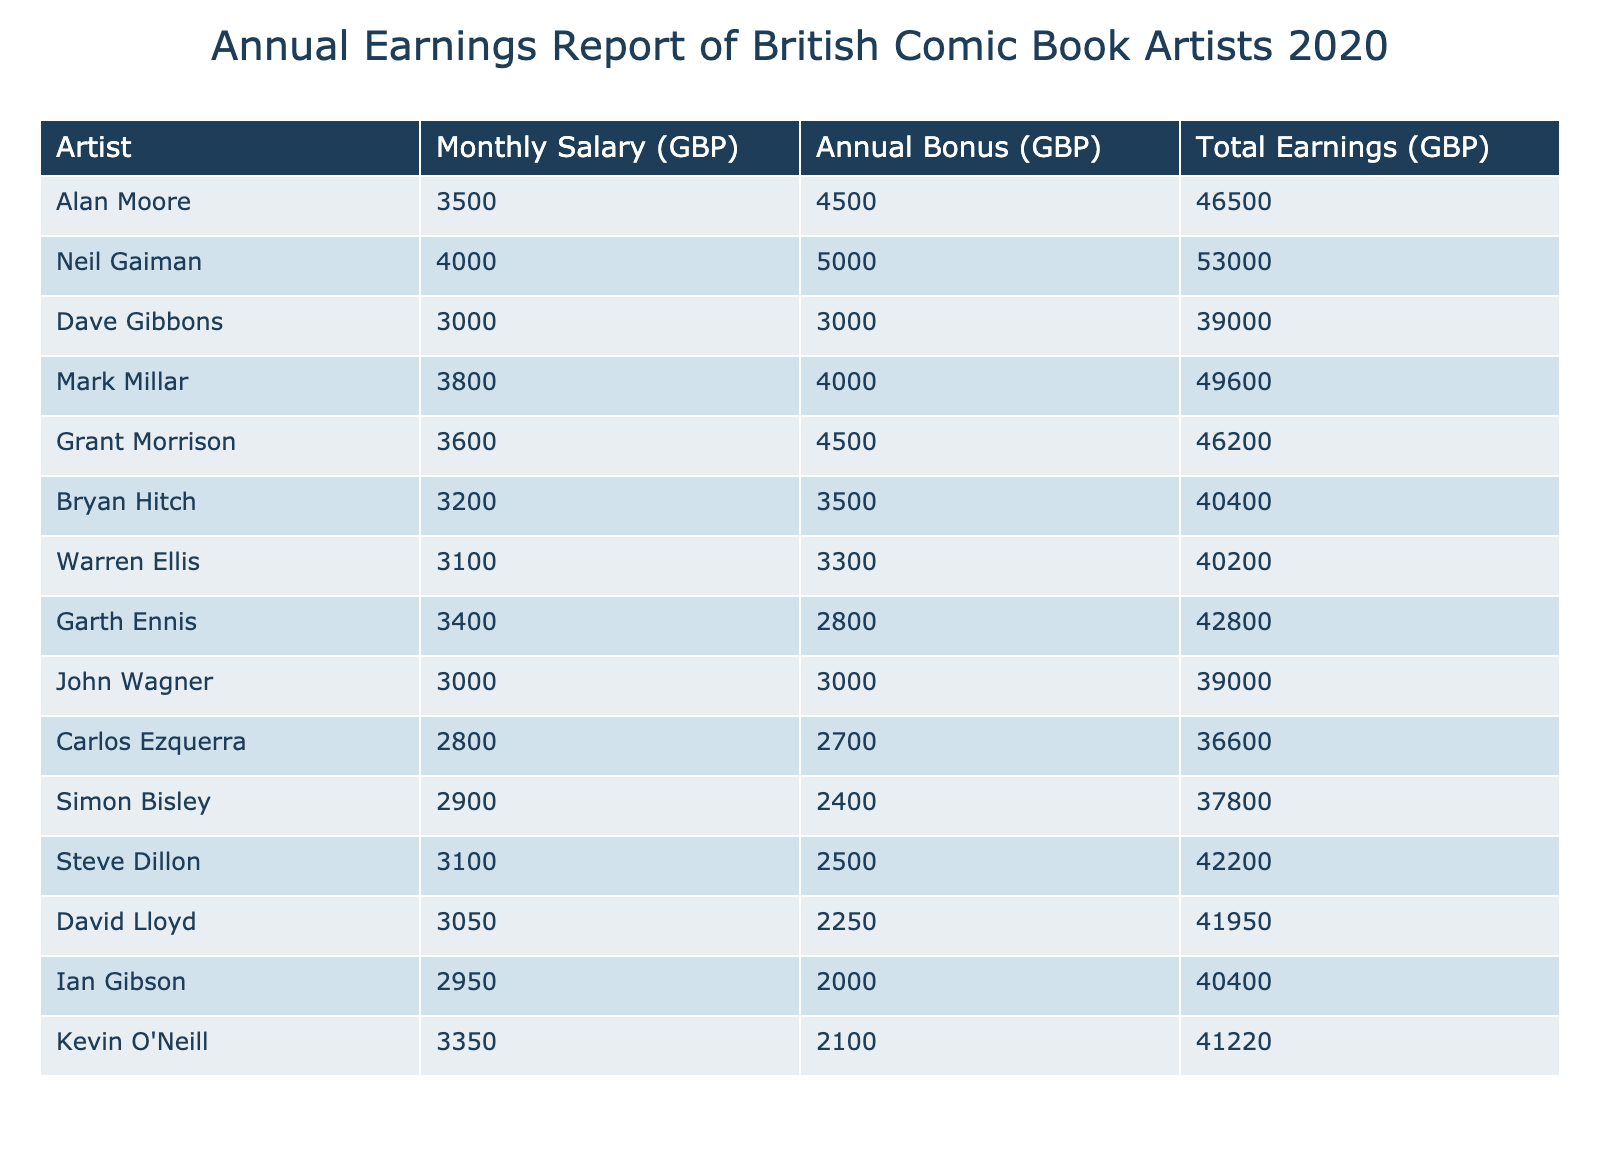What is the total earnings for Neil Gaiman? Neil Gaiman's total earnings are listed directly in the table under the "Total Earnings" column, which shows £53,000.
Answer: £53,000 Which artist earned the least in total earnings? By going through the "Total Earnings" column, Carlos Ezquerra has the lowest total earnings at £36,600, which is the smallest value in that column compared to all other artists.
Answer: Carlos Ezquerra What is the average monthly salary of all the artists listed? To find the average monthly salary, first, sum all the monthly salaries: (3500 + 4000 + 3000 + 3800 + 3600 + 3200 + 3100 + 3400 + 3000 + 2800 + 2900 + 3100 + 3050 + 2950 + 3350) = 49,800. There are 15 artists, so the average monthly salary is 49,800 / 15 = £3,320.
Answer: £3,320 Is there any artist with an annual bonus greater than £4,000? Checking the "Annual Bonus" column, we find that several artists, including Alan Moore (£4,500), Neil Gaiman (£5,000), Mark Millar (£4,000), and Grant Morrison (£4,500), have bonuses greater than £4,000. Thus, the answer is yes.
Answer: Yes What is the difference in total earnings between Alan Moore and Grant Morrison? Alan Moore has total earnings of £46,500 and Grant Morrison has total earnings of £46,200. The difference is found by subtracting Grant Morrison's earnings from Alan Moore's: £46,500 - £46,200 = £300.
Answer: £300 What percentage of the total earnings does Neil Gaiman account for among all artists? First, sum the total earnings of all artists: £46500 + £53000 + £39000 + £49600 + £46200 + £40400 + £40200 + £42800 + £39000 + £36600 + £37800 + £42200 + £41950 + £40400 + £41220 = £675,470. Then, calculate the percentage: (£53,000 / £675,470) * 100 ≈ 7.85%.
Answer: 7.85% Which artist earned more in total: Mark Millar or Garth Ennis? Mark Millar's total earnings are £49,600 and Garth Ennis' are £42,800. Comparing these figures shows that Mark Millar earned more than Garth Ennis.
Answer: Mark Millar Is Kevin O'Neill's total earnings less than £40,000? Referring to the "Total Earnings" column, Kevin O'Neill has £41,220, which is greater than £40,000. Therefore, the answer is no.
Answer: No 